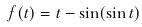<formula> <loc_0><loc_0><loc_500><loc_500>f ( t ) = t - \sin ( \sin t )</formula> 